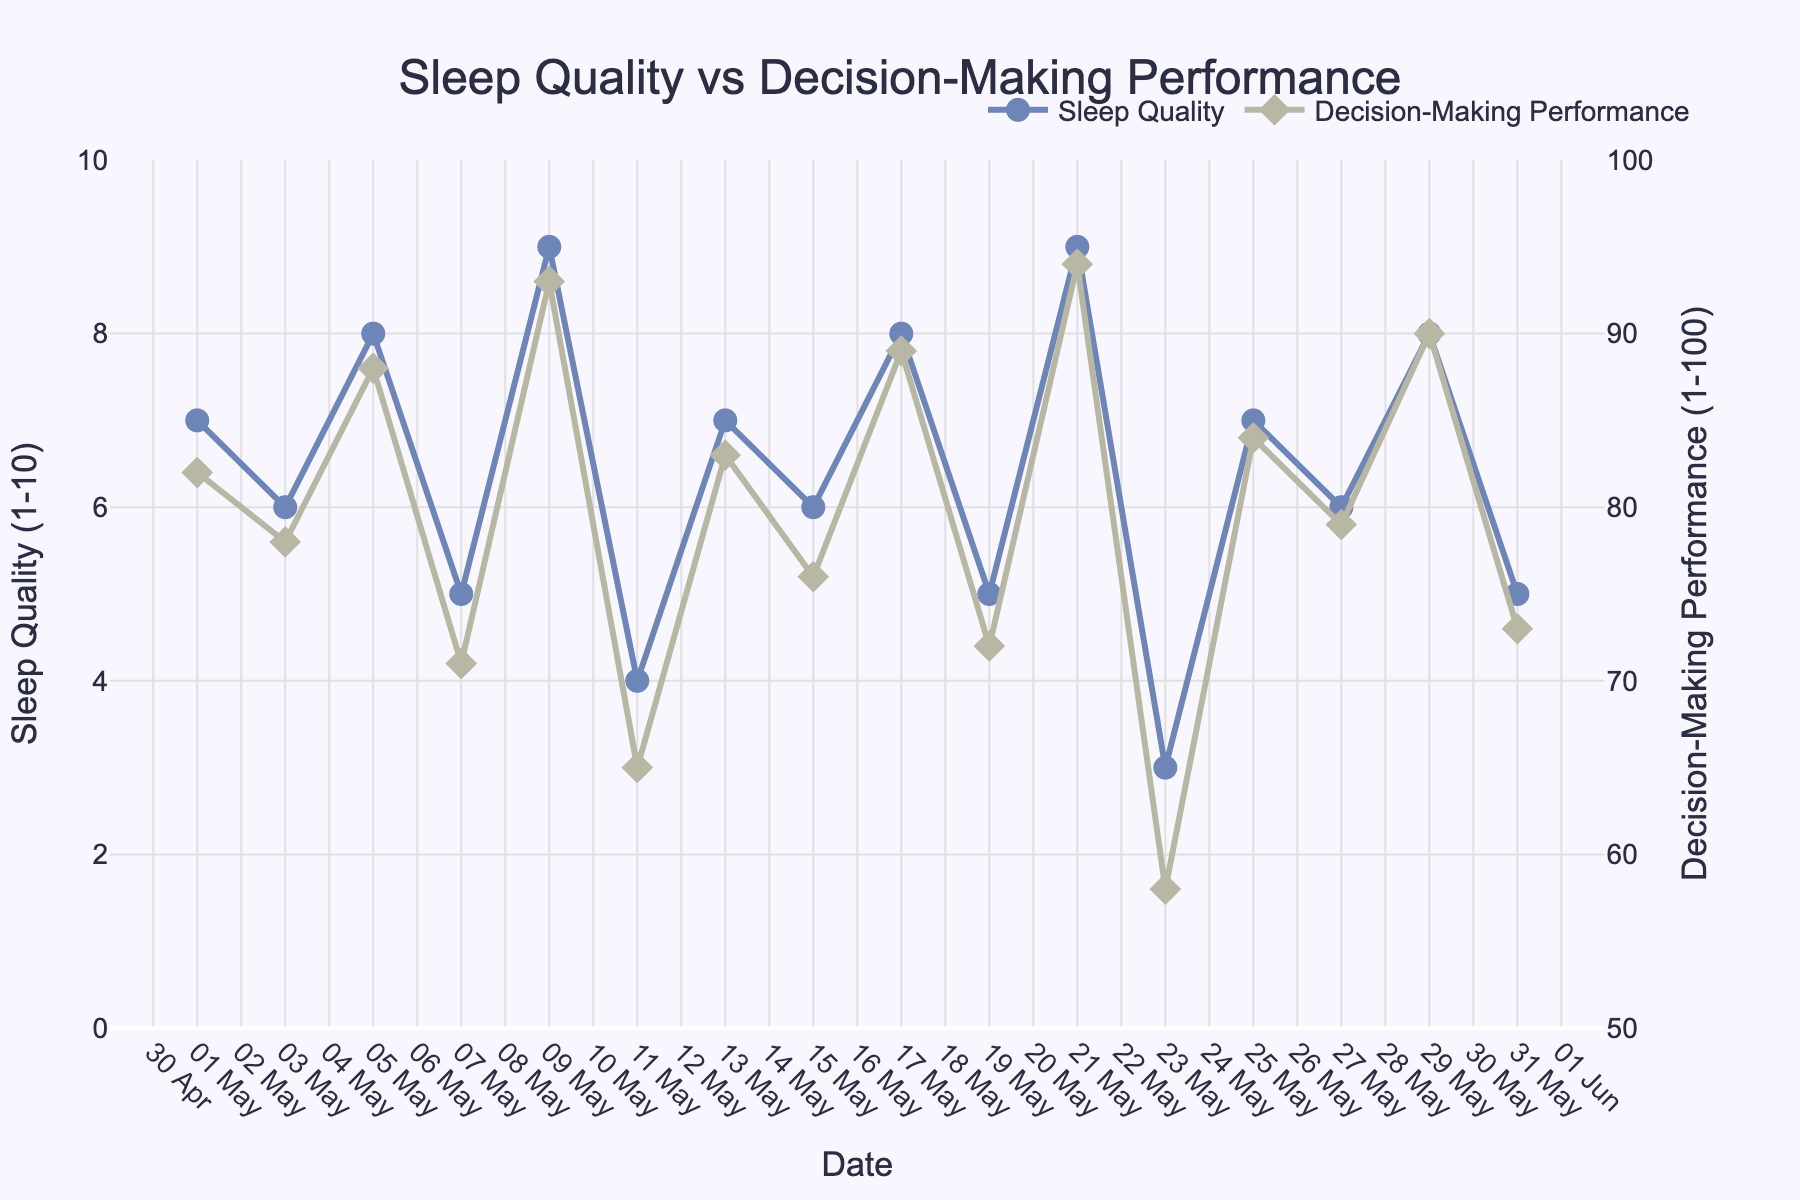What's the general trend between sleep quality and decision-making performance over the month? By observing the chart, we can see that when sleep quality is high, decision-making performance also tends to be high, indicating a positive correlation. Conversely, lower sleep quality is associated with poorer decision-making performance.
Answer: Positive correlation Which date shows the highest sleep quality? Reviewing the sleep quality data points on the chart, the highest sleep quality value of 9 occurs on May 9 and May 21.
Answer: May 9 and May 21 How does the decision-making performance on May 23 compare to other days? The decision-making performance on May 23 is 58, which is the lowest value recorded on the chart, so it is lower than all other days.
Answer: It is the lowest What is the average decision-making performance for the days when the sleep quality is rated as 7? The days with sleep quality rated at 7 are May 1, May 13, and May 25, with corresponding performance values of 82, 83, and 84. The average is (82 + 83 + 84)/3, which equals 83.
Answer: 83 What difference in sleep quality is observed between May 11 and May 15, and how does that relate to decision-making performance? On May 11, sleep quality is 4, and on May 15, it is 6. The difference is 6 - 4 = 2. Correspondingly, decision-making performance improves from 65 to 76, a difference of 11.
Answer: Sleep quality difference: 2, performance difference: 11 Does any date show an equal value for both sleep quality and decision-making performance? By examining the chart, no date shows equal values for sleep quality and decision-making performance. Sleep quality ranges up to 10, while performance ranges up to 100.
Answer: No Which date has the highest decision-making performance, and what was the sleep quality on that day? By locating the peak point for decision-making performance, we identify May 21 with a performance value of 94. The sleep quality on that day was 9.
Answer: May 21, sleep quality: 9 On which date is the difference between sleep quality and decision-making performance the smallest? Reviewing the data points, May 1 has sleep quality of 7 and decision-making performance of 82, a difference of 82 - 7 = 75. Checking other dates reveals larger differences.
Answer: May 1 What is the sum of sleep quality ratings for the first five recorded dates in the month? The first five dates are May 1, 3, 5, 7, and 9 with ratings of 7, 6, 8, 5, and 9 respectively. Summing these up gives 7 + 6 + 8 + 5 + 9 = 35.
Answer: 35 